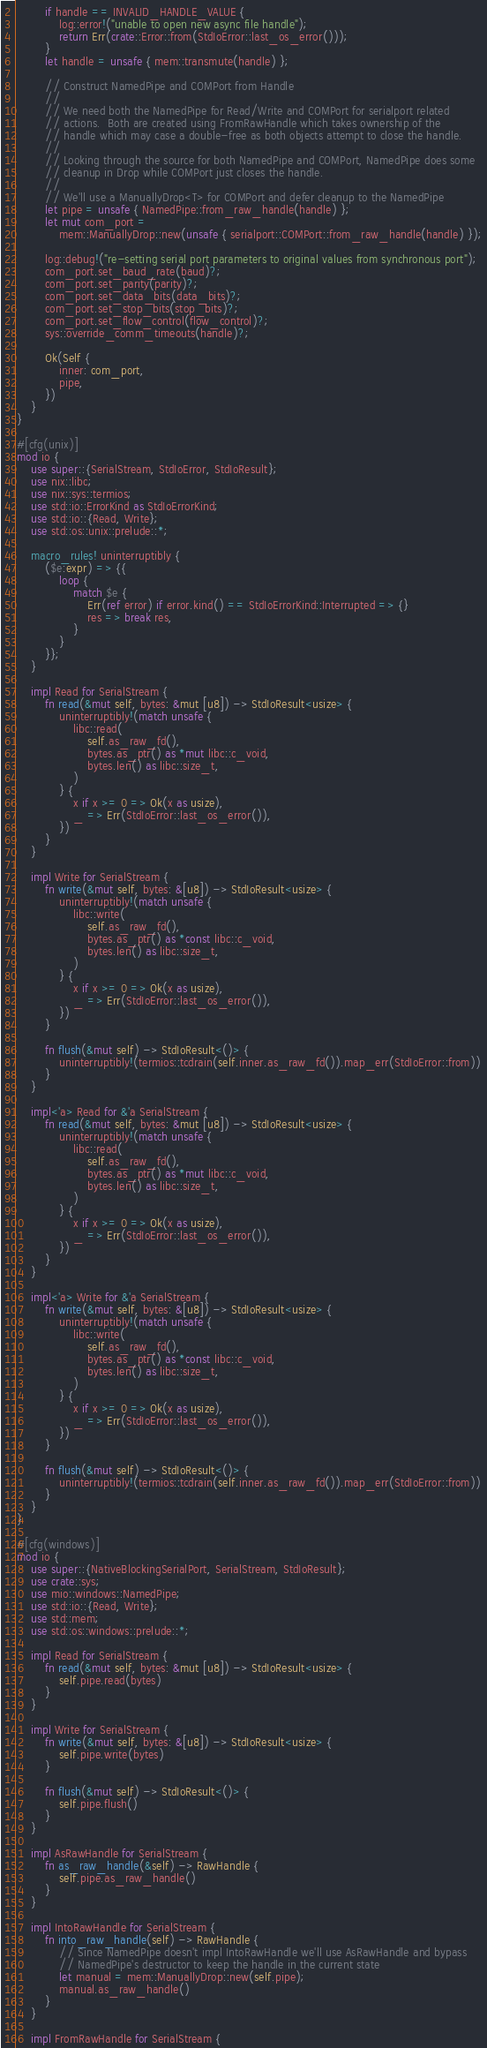<code> <loc_0><loc_0><loc_500><loc_500><_Rust_>
        if handle == INVALID_HANDLE_VALUE {
            log::error!("unable to open new async file handle");
            return Err(crate::Error::from(StdIoError::last_os_error()));
        }
        let handle = unsafe { mem::transmute(handle) };

        // Construct NamedPipe and COMPort from Handle
        //
        // We need both the NamedPipe for Read/Write and COMPort for serialport related
        // actions.  Both are created using FromRawHandle which takes ownership of the
        // handle which may case a double-free as both objects attempt to close the handle.
        //
        // Looking through the source for both NamedPipe and COMPort, NamedPipe does some
        // cleanup in Drop while COMPort just closes the handle.
        //
        // We'll use a ManuallyDrop<T> for COMPort and defer cleanup to the NamedPipe
        let pipe = unsafe { NamedPipe::from_raw_handle(handle) };
        let mut com_port =
            mem::ManuallyDrop::new(unsafe { serialport::COMPort::from_raw_handle(handle) });

        log::debug!("re-setting serial port parameters to original values from synchronous port");
        com_port.set_baud_rate(baud)?;
        com_port.set_parity(parity)?;
        com_port.set_data_bits(data_bits)?;
        com_port.set_stop_bits(stop_bits)?;
        com_port.set_flow_control(flow_control)?;
        sys::override_comm_timeouts(handle)?;

        Ok(Self {
            inner: com_port,
            pipe,
        })
    }
}

#[cfg(unix)]
mod io {
    use super::{SerialStream, StdIoError, StdIoResult};
    use nix::libc;
    use nix::sys::termios;
    use std::io::ErrorKind as StdIoErrorKind;
    use std::io::{Read, Write};
    use std::os::unix::prelude::*;

    macro_rules! uninterruptibly {
        ($e:expr) => {{
            loop {
                match $e {
                    Err(ref error) if error.kind() == StdIoErrorKind::Interrupted => {}
                    res => break res,
                }
            }
        }};
    }

    impl Read for SerialStream {
        fn read(&mut self, bytes: &mut [u8]) -> StdIoResult<usize> {
            uninterruptibly!(match unsafe {
                libc::read(
                    self.as_raw_fd(),
                    bytes.as_ptr() as *mut libc::c_void,
                    bytes.len() as libc::size_t,
                )
            } {
                x if x >= 0 => Ok(x as usize),
                _ => Err(StdIoError::last_os_error()),
            })
        }
    }

    impl Write for SerialStream {
        fn write(&mut self, bytes: &[u8]) -> StdIoResult<usize> {
            uninterruptibly!(match unsafe {
                libc::write(
                    self.as_raw_fd(),
                    bytes.as_ptr() as *const libc::c_void,
                    bytes.len() as libc::size_t,
                )
            } {
                x if x >= 0 => Ok(x as usize),
                _ => Err(StdIoError::last_os_error()),
            })
        }

        fn flush(&mut self) -> StdIoResult<()> {
            uninterruptibly!(termios::tcdrain(self.inner.as_raw_fd()).map_err(StdIoError::from))
        }
    }

    impl<'a> Read for &'a SerialStream {
        fn read(&mut self, bytes: &mut [u8]) -> StdIoResult<usize> {
            uninterruptibly!(match unsafe {
                libc::read(
                    self.as_raw_fd(),
                    bytes.as_ptr() as *mut libc::c_void,
                    bytes.len() as libc::size_t,
                )
            } {
                x if x >= 0 => Ok(x as usize),
                _ => Err(StdIoError::last_os_error()),
            })
        }
    }

    impl<'a> Write for &'a SerialStream {
        fn write(&mut self, bytes: &[u8]) -> StdIoResult<usize> {
            uninterruptibly!(match unsafe {
                libc::write(
                    self.as_raw_fd(),
                    bytes.as_ptr() as *const libc::c_void,
                    bytes.len() as libc::size_t,
                )
            } {
                x if x >= 0 => Ok(x as usize),
                _ => Err(StdIoError::last_os_error()),
            })
        }

        fn flush(&mut self) -> StdIoResult<()> {
            uninterruptibly!(termios::tcdrain(self.inner.as_raw_fd()).map_err(StdIoError::from))
        }
    }
}

#[cfg(windows)]
mod io {
    use super::{NativeBlockingSerialPort, SerialStream, StdIoResult};
    use crate::sys;
    use mio::windows::NamedPipe;
    use std::io::{Read, Write};
    use std::mem;
    use std::os::windows::prelude::*;

    impl Read for SerialStream {
        fn read(&mut self, bytes: &mut [u8]) -> StdIoResult<usize> {
            self.pipe.read(bytes)
        }
    }

    impl Write for SerialStream {
        fn write(&mut self, bytes: &[u8]) -> StdIoResult<usize> {
            self.pipe.write(bytes)
        }

        fn flush(&mut self) -> StdIoResult<()> {
            self.pipe.flush()
        }
    }

    impl AsRawHandle for SerialStream {
        fn as_raw_handle(&self) -> RawHandle {
            self.pipe.as_raw_handle()
        }
    }

    impl IntoRawHandle for SerialStream {
        fn into_raw_handle(self) -> RawHandle {
            // Since NamedPipe doesn't impl IntoRawHandle we'll use AsRawHandle and bypass
            // NamedPipe's destructor to keep the handle in the current state
            let manual = mem::ManuallyDrop::new(self.pipe);
            manual.as_raw_handle()
        }
    }

    impl FromRawHandle for SerialStream {</code> 